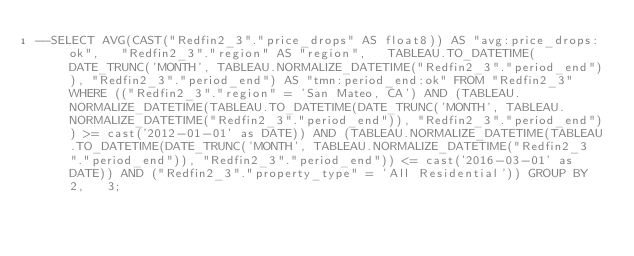<code> <loc_0><loc_0><loc_500><loc_500><_SQL_>--SELECT AVG(CAST("Redfin2_3"."price_drops" AS float8)) AS "avg:price_drops:ok",   "Redfin2_3"."region" AS "region",   TABLEAU.TO_DATETIME(DATE_TRUNC('MONTH', TABLEAU.NORMALIZE_DATETIME("Redfin2_3"."period_end")), "Redfin2_3"."period_end") AS "tmn:period_end:ok" FROM "Redfin2_3" WHERE (("Redfin2_3"."region" = 'San Mateo, CA') AND (TABLEAU.NORMALIZE_DATETIME(TABLEAU.TO_DATETIME(DATE_TRUNC('MONTH', TABLEAU.NORMALIZE_DATETIME("Redfin2_3"."period_end")), "Redfin2_3"."period_end")) >= cast('2012-01-01' as DATE)) AND (TABLEAU.NORMALIZE_DATETIME(TABLEAU.TO_DATETIME(DATE_TRUNC('MONTH', TABLEAU.NORMALIZE_DATETIME("Redfin2_3"."period_end")), "Redfin2_3"."period_end")) <= cast('2016-03-01' as DATE)) AND ("Redfin2_3"."property_type" = 'All Residential')) GROUP BY 2,   3;
</code> 